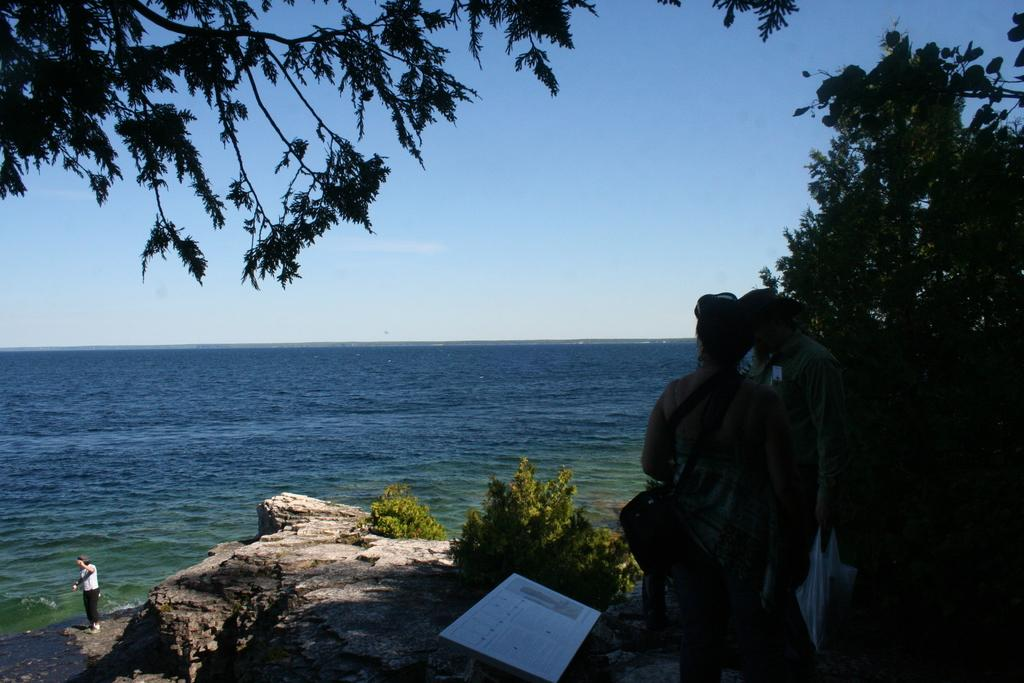What natural elements are present in the image? The image contains the sky and the sea. What are the two persons in the image doing? The two persons are standing on the ground in front of the sea. What type of vegetation can be seen in the image? Trees are visible in the image. How many pages of the book can be seen in the image? There is no book present in the image, so it is not possible to determine the number of pages. What type of pizzas are the rats eating in the image? There are no rats or pizzas present in the image. 